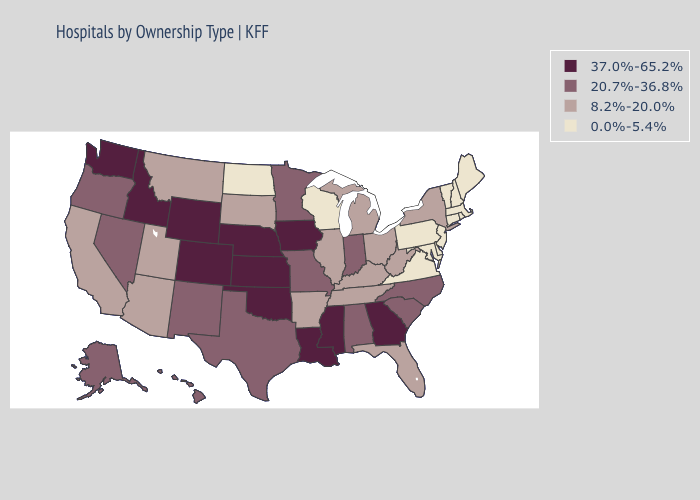Name the states that have a value in the range 20.7%-36.8%?
Answer briefly. Alabama, Alaska, Hawaii, Indiana, Minnesota, Missouri, Nevada, New Mexico, North Carolina, Oregon, South Carolina, Texas. Does California have a lower value than Minnesota?
Concise answer only. Yes. What is the highest value in the MidWest ?
Quick response, please. 37.0%-65.2%. Which states have the highest value in the USA?
Keep it brief. Colorado, Georgia, Idaho, Iowa, Kansas, Louisiana, Mississippi, Nebraska, Oklahoma, Washington, Wyoming. What is the value of Massachusetts?
Write a very short answer. 0.0%-5.4%. Does the first symbol in the legend represent the smallest category?
Quick response, please. No. Among the states that border Vermont , which have the lowest value?
Be succinct. Massachusetts, New Hampshire. Which states have the highest value in the USA?
Give a very brief answer. Colorado, Georgia, Idaho, Iowa, Kansas, Louisiana, Mississippi, Nebraska, Oklahoma, Washington, Wyoming. What is the value of Idaho?
Answer briefly. 37.0%-65.2%. Which states hav the highest value in the Northeast?
Answer briefly. New York. Name the states that have a value in the range 20.7%-36.8%?
Give a very brief answer. Alabama, Alaska, Hawaii, Indiana, Minnesota, Missouri, Nevada, New Mexico, North Carolina, Oregon, South Carolina, Texas. What is the value of Alaska?
Quick response, please. 20.7%-36.8%. Name the states that have a value in the range 8.2%-20.0%?
Answer briefly. Arizona, Arkansas, California, Florida, Illinois, Kentucky, Michigan, Montana, New York, Ohio, South Dakota, Tennessee, Utah, West Virginia. Among the states that border West Virginia , which have the lowest value?
Keep it brief. Maryland, Pennsylvania, Virginia. What is the value of Florida?
Short answer required. 8.2%-20.0%. 